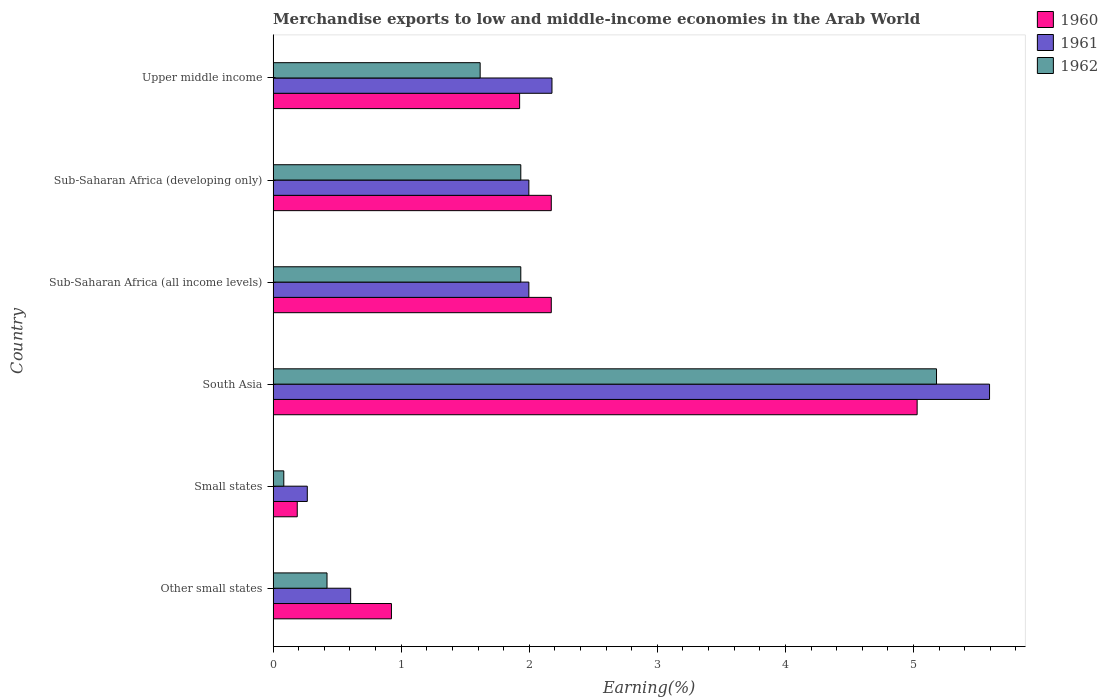How many groups of bars are there?
Keep it short and to the point. 6. Are the number of bars on each tick of the Y-axis equal?
Offer a terse response. Yes. How many bars are there on the 1st tick from the top?
Offer a terse response. 3. In how many cases, is the number of bars for a given country not equal to the number of legend labels?
Offer a terse response. 0. What is the percentage of amount earned from merchandise exports in 1961 in Sub-Saharan Africa (all income levels)?
Provide a succinct answer. 2. Across all countries, what is the maximum percentage of amount earned from merchandise exports in 1960?
Keep it short and to the point. 5.03. Across all countries, what is the minimum percentage of amount earned from merchandise exports in 1960?
Offer a very short reply. 0.19. In which country was the percentage of amount earned from merchandise exports in 1960 minimum?
Provide a succinct answer. Small states. What is the total percentage of amount earned from merchandise exports in 1962 in the graph?
Your answer should be very brief. 11.17. What is the difference between the percentage of amount earned from merchandise exports in 1960 in Small states and that in South Asia?
Provide a short and direct response. -4.84. What is the difference between the percentage of amount earned from merchandise exports in 1960 in Sub-Saharan Africa (developing only) and the percentage of amount earned from merchandise exports in 1962 in South Asia?
Provide a succinct answer. -3.01. What is the average percentage of amount earned from merchandise exports in 1961 per country?
Your answer should be compact. 2.11. What is the difference between the percentage of amount earned from merchandise exports in 1962 and percentage of amount earned from merchandise exports in 1961 in Small states?
Give a very brief answer. -0.18. In how many countries, is the percentage of amount earned from merchandise exports in 1961 greater than 2.2 %?
Give a very brief answer. 1. What is the ratio of the percentage of amount earned from merchandise exports in 1960 in Small states to that in Upper middle income?
Keep it short and to the point. 0.1. Is the percentage of amount earned from merchandise exports in 1961 in South Asia less than that in Sub-Saharan Africa (developing only)?
Offer a terse response. No. Is the difference between the percentage of amount earned from merchandise exports in 1962 in Sub-Saharan Africa (all income levels) and Sub-Saharan Africa (developing only) greater than the difference between the percentage of amount earned from merchandise exports in 1961 in Sub-Saharan Africa (all income levels) and Sub-Saharan Africa (developing only)?
Your answer should be compact. No. What is the difference between the highest and the second highest percentage of amount earned from merchandise exports in 1962?
Your answer should be compact. 3.25. What is the difference between the highest and the lowest percentage of amount earned from merchandise exports in 1962?
Your answer should be compact. 5.1. In how many countries, is the percentage of amount earned from merchandise exports in 1962 greater than the average percentage of amount earned from merchandise exports in 1962 taken over all countries?
Provide a short and direct response. 3. Is the sum of the percentage of amount earned from merchandise exports in 1962 in Other small states and Sub-Saharan Africa (developing only) greater than the maximum percentage of amount earned from merchandise exports in 1961 across all countries?
Ensure brevity in your answer.  No. What does the 1st bar from the top in Small states represents?
Give a very brief answer. 1962. What does the 3rd bar from the bottom in South Asia represents?
Your answer should be very brief. 1962. How many bars are there?
Your response must be concise. 18. Are all the bars in the graph horizontal?
Your response must be concise. Yes. Where does the legend appear in the graph?
Your response must be concise. Top right. How many legend labels are there?
Your response must be concise. 3. How are the legend labels stacked?
Your answer should be compact. Vertical. What is the title of the graph?
Provide a short and direct response. Merchandise exports to low and middle-income economies in the Arab World. Does "1991" appear as one of the legend labels in the graph?
Make the answer very short. No. What is the label or title of the X-axis?
Give a very brief answer. Earning(%). What is the label or title of the Y-axis?
Make the answer very short. Country. What is the Earning(%) in 1960 in Other small states?
Provide a succinct answer. 0.92. What is the Earning(%) in 1961 in Other small states?
Provide a succinct answer. 0.61. What is the Earning(%) of 1962 in Other small states?
Offer a very short reply. 0.42. What is the Earning(%) of 1960 in Small states?
Keep it short and to the point. 0.19. What is the Earning(%) in 1961 in Small states?
Ensure brevity in your answer.  0.27. What is the Earning(%) in 1962 in Small states?
Your answer should be very brief. 0.08. What is the Earning(%) in 1960 in South Asia?
Provide a succinct answer. 5.03. What is the Earning(%) in 1961 in South Asia?
Offer a very short reply. 5.59. What is the Earning(%) of 1962 in South Asia?
Your response must be concise. 5.18. What is the Earning(%) of 1960 in Sub-Saharan Africa (all income levels)?
Your answer should be very brief. 2.17. What is the Earning(%) in 1961 in Sub-Saharan Africa (all income levels)?
Your answer should be compact. 2. What is the Earning(%) in 1962 in Sub-Saharan Africa (all income levels)?
Provide a succinct answer. 1.93. What is the Earning(%) of 1960 in Sub-Saharan Africa (developing only)?
Make the answer very short. 2.17. What is the Earning(%) in 1961 in Sub-Saharan Africa (developing only)?
Provide a short and direct response. 2. What is the Earning(%) of 1962 in Sub-Saharan Africa (developing only)?
Make the answer very short. 1.93. What is the Earning(%) of 1960 in Upper middle income?
Your answer should be very brief. 1.92. What is the Earning(%) of 1961 in Upper middle income?
Offer a very short reply. 2.18. What is the Earning(%) of 1962 in Upper middle income?
Keep it short and to the point. 1.62. Across all countries, what is the maximum Earning(%) in 1960?
Your answer should be compact. 5.03. Across all countries, what is the maximum Earning(%) of 1961?
Provide a short and direct response. 5.59. Across all countries, what is the maximum Earning(%) in 1962?
Your response must be concise. 5.18. Across all countries, what is the minimum Earning(%) of 1960?
Your response must be concise. 0.19. Across all countries, what is the minimum Earning(%) in 1961?
Offer a terse response. 0.27. Across all countries, what is the minimum Earning(%) of 1962?
Provide a short and direct response. 0.08. What is the total Earning(%) of 1960 in the graph?
Your answer should be compact. 12.41. What is the total Earning(%) in 1961 in the graph?
Provide a succinct answer. 12.64. What is the total Earning(%) of 1962 in the graph?
Provide a short and direct response. 11.17. What is the difference between the Earning(%) in 1960 in Other small states and that in Small states?
Provide a short and direct response. 0.74. What is the difference between the Earning(%) in 1961 in Other small states and that in Small states?
Your response must be concise. 0.34. What is the difference between the Earning(%) of 1962 in Other small states and that in Small states?
Make the answer very short. 0.34. What is the difference between the Earning(%) in 1960 in Other small states and that in South Asia?
Offer a terse response. -4.1. What is the difference between the Earning(%) of 1961 in Other small states and that in South Asia?
Your response must be concise. -4.99. What is the difference between the Earning(%) in 1962 in Other small states and that in South Asia?
Your answer should be very brief. -4.76. What is the difference between the Earning(%) of 1960 in Other small states and that in Sub-Saharan Africa (all income levels)?
Your answer should be very brief. -1.25. What is the difference between the Earning(%) in 1961 in Other small states and that in Sub-Saharan Africa (all income levels)?
Your answer should be very brief. -1.39. What is the difference between the Earning(%) in 1962 in Other small states and that in Sub-Saharan Africa (all income levels)?
Keep it short and to the point. -1.51. What is the difference between the Earning(%) in 1960 in Other small states and that in Sub-Saharan Africa (developing only)?
Keep it short and to the point. -1.25. What is the difference between the Earning(%) in 1961 in Other small states and that in Sub-Saharan Africa (developing only)?
Ensure brevity in your answer.  -1.39. What is the difference between the Earning(%) in 1962 in Other small states and that in Sub-Saharan Africa (developing only)?
Your answer should be compact. -1.51. What is the difference between the Earning(%) in 1960 in Other small states and that in Upper middle income?
Offer a terse response. -1. What is the difference between the Earning(%) in 1961 in Other small states and that in Upper middle income?
Keep it short and to the point. -1.57. What is the difference between the Earning(%) in 1962 in Other small states and that in Upper middle income?
Offer a terse response. -1.2. What is the difference between the Earning(%) in 1960 in Small states and that in South Asia?
Provide a succinct answer. -4.84. What is the difference between the Earning(%) of 1961 in Small states and that in South Asia?
Ensure brevity in your answer.  -5.33. What is the difference between the Earning(%) of 1962 in Small states and that in South Asia?
Provide a short and direct response. -5.1. What is the difference between the Earning(%) in 1960 in Small states and that in Sub-Saharan Africa (all income levels)?
Ensure brevity in your answer.  -1.98. What is the difference between the Earning(%) of 1961 in Small states and that in Sub-Saharan Africa (all income levels)?
Provide a short and direct response. -1.73. What is the difference between the Earning(%) in 1962 in Small states and that in Sub-Saharan Africa (all income levels)?
Your response must be concise. -1.85. What is the difference between the Earning(%) in 1960 in Small states and that in Sub-Saharan Africa (developing only)?
Ensure brevity in your answer.  -1.98. What is the difference between the Earning(%) in 1961 in Small states and that in Sub-Saharan Africa (developing only)?
Keep it short and to the point. -1.73. What is the difference between the Earning(%) in 1962 in Small states and that in Sub-Saharan Africa (developing only)?
Offer a very short reply. -1.85. What is the difference between the Earning(%) in 1960 in Small states and that in Upper middle income?
Make the answer very short. -1.74. What is the difference between the Earning(%) in 1961 in Small states and that in Upper middle income?
Provide a short and direct response. -1.91. What is the difference between the Earning(%) of 1962 in Small states and that in Upper middle income?
Ensure brevity in your answer.  -1.53. What is the difference between the Earning(%) in 1960 in South Asia and that in Sub-Saharan Africa (all income levels)?
Provide a succinct answer. 2.86. What is the difference between the Earning(%) of 1961 in South Asia and that in Sub-Saharan Africa (all income levels)?
Make the answer very short. 3.6. What is the difference between the Earning(%) of 1962 in South Asia and that in Sub-Saharan Africa (all income levels)?
Offer a very short reply. 3.25. What is the difference between the Earning(%) in 1960 in South Asia and that in Sub-Saharan Africa (developing only)?
Offer a very short reply. 2.86. What is the difference between the Earning(%) of 1961 in South Asia and that in Sub-Saharan Africa (developing only)?
Ensure brevity in your answer.  3.6. What is the difference between the Earning(%) in 1962 in South Asia and that in Sub-Saharan Africa (developing only)?
Provide a short and direct response. 3.25. What is the difference between the Earning(%) in 1960 in South Asia and that in Upper middle income?
Offer a terse response. 3.1. What is the difference between the Earning(%) of 1961 in South Asia and that in Upper middle income?
Give a very brief answer. 3.42. What is the difference between the Earning(%) in 1962 in South Asia and that in Upper middle income?
Offer a very short reply. 3.56. What is the difference between the Earning(%) of 1960 in Sub-Saharan Africa (all income levels) and that in Sub-Saharan Africa (developing only)?
Your answer should be very brief. 0. What is the difference between the Earning(%) of 1961 in Sub-Saharan Africa (all income levels) and that in Sub-Saharan Africa (developing only)?
Provide a short and direct response. 0. What is the difference between the Earning(%) of 1960 in Sub-Saharan Africa (all income levels) and that in Upper middle income?
Ensure brevity in your answer.  0.25. What is the difference between the Earning(%) in 1961 in Sub-Saharan Africa (all income levels) and that in Upper middle income?
Keep it short and to the point. -0.18. What is the difference between the Earning(%) in 1962 in Sub-Saharan Africa (all income levels) and that in Upper middle income?
Make the answer very short. 0.32. What is the difference between the Earning(%) in 1960 in Sub-Saharan Africa (developing only) and that in Upper middle income?
Your response must be concise. 0.25. What is the difference between the Earning(%) in 1961 in Sub-Saharan Africa (developing only) and that in Upper middle income?
Offer a terse response. -0.18. What is the difference between the Earning(%) in 1962 in Sub-Saharan Africa (developing only) and that in Upper middle income?
Ensure brevity in your answer.  0.32. What is the difference between the Earning(%) in 1960 in Other small states and the Earning(%) in 1961 in Small states?
Give a very brief answer. 0.66. What is the difference between the Earning(%) in 1960 in Other small states and the Earning(%) in 1962 in Small states?
Keep it short and to the point. 0.84. What is the difference between the Earning(%) of 1961 in Other small states and the Earning(%) of 1962 in Small states?
Your answer should be very brief. 0.52. What is the difference between the Earning(%) of 1960 in Other small states and the Earning(%) of 1961 in South Asia?
Offer a terse response. -4.67. What is the difference between the Earning(%) in 1960 in Other small states and the Earning(%) in 1962 in South Asia?
Provide a succinct answer. -4.26. What is the difference between the Earning(%) of 1961 in Other small states and the Earning(%) of 1962 in South Asia?
Your answer should be compact. -4.57. What is the difference between the Earning(%) in 1960 in Other small states and the Earning(%) in 1961 in Sub-Saharan Africa (all income levels)?
Your answer should be very brief. -1.07. What is the difference between the Earning(%) of 1960 in Other small states and the Earning(%) of 1962 in Sub-Saharan Africa (all income levels)?
Offer a very short reply. -1.01. What is the difference between the Earning(%) of 1961 in Other small states and the Earning(%) of 1962 in Sub-Saharan Africa (all income levels)?
Your answer should be compact. -1.33. What is the difference between the Earning(%) of 1960 in Other small states and the Earning(%) of 1961 in Sub-Saharan Africa (developing only)?
Your response must be concise. -1.07. What is the difference between the Earning(%) in 1960 in Other small states and the Earning(%) in 1962 in Sub-Saharan Africa (developing only)?
Your response must be concise. -1.01. What is the difference between the Earning(%) in 1961 in Other small states and the Earning(%) in 1962 in Sub-Saharan Africa (developing only)?
Offer a terse response. -1.33. What is the difference between the Earning(%) of 1960 in Other small states and the Earning(%) of 1961 in Upper middle income?
Ensure brevity in your answer.  -1.25. What is the difference between the Earning(%) in 1960 in Other small states and the Earning(%) in 1962 in Upper middle income?
Offer a very short reply. -0.69. What is the difference between the Earning(%) of 1961 in Other small states and the Earning(%) of 1962 in Upper middle income?
Give a very brief answer. -1.01. What is the difference between the Earning(%) in 1960 in Small states and the Earning(%) in 1961 in South Asia?
Your answer should be compact. -5.41. What is the difference between the Earning(%) of 1960 in Small states and the Earning(%) of 1962 in South Asia?
Offer a terse response. -4.99. What is the difference between the Earning(%) of 1961 in Small states and the Earning(%) of 1962 in South Asia?
Your answer should be compact. -4.91. What is the difference between the Earning(%) of 1960 in Small states and the Earning(%) of 1961 in Sub-Saharan Africa (all income levels)?
Ensure brevity in your answer.  -1.81. What is the difference between the Earning(%) of 1960 in Small states and the Earning(%) of 1962 in Sub-Saharan Africa (all income levels)?
Your answer should be compact. -1.75. What is the difference between the Earning(%) of 1961 in Small states and the Earning(%) of 1962 in Sub-Saharan Africa (all income levels)?
Ensure brevity in your answer.  -1.67. What is the difference between the Earning(%) in 1960 in Small states and the Earning(%) in 1961 in Sub-Saharan Africa (developing only)?
Keep it short and to the point. -1.81. What is the difference between the Earning(%) in 1960 in Small states and the Earning(%) in 1962 in Sub-Saharan Africa (developing only)?
Ensure brevity in your answer.  -1.75. What is the difference between the Earning(%) of 1961 in Small states and the Earning(%) of 1962 in Sub-Saharan Africa (developing only)?
Provide a short and direct response. -1.67. What is the difference between the Earning(%) in 1960 in Small states and the Earning(%) in 1961 in Upper middle income?
Your response must be concise. -1.99. What is the difference between the Earning(%) of 1960 in Small states and the Earning(%) of 1962 in Upper middle income?
Offer a very short reply. -1.43. What is the difference between the Earning(%) in 1961 in Small states and the Earning(%) in 1962 in Upper middle income?
Offer a terse response. -1.35. What is the difference between the Earning(%) in 1960 in South Asia and the Earning(%) in 1961 in Sub-Saharan Africa (all income levels)?
Offer a terse response. 3.03. What is the difference between the Earning(%) of 1960 in South Asia and the Earning(%) of 1962 in Sub-Saharan Africa (all income levels)?
Your response must be concise. 3.09. What is the difference between the Earning(%) of 1961 in South Asia and the Earning(%) of 1962 in Sub-Saharan Africa (all income levels)?
Make the answer very short. 3.66. What is the difference between the Earning(%) in 1960 in South Asia and the Earning(%) in 1961 in Sub-Saharan Africa (developing only)?
Offer a very short reply. 3.03. What is the difference between the Earning(%) of 1960 in South Asia and the Earning(%) of 1962 in Sub-Saharan Africa (developing only)?
Give a very brief answer. 3.09. What is the difference between the Earning(%) of 1961 in South Asia and the Earning(%) of 1962 in Sub-Saharan Africa (developing only)?
Make the answer very short. 3.66. What is the difference between the Earning(%) of 1960 in South Asia and the Earning(%) of 1961 in Upper middle income?
Your answer should be very brief. 2.85. What is the difference between the Earning(%) of 1960 in South Asia and the Earning(%) of 1962 in Upper middle income?
Your answer should be very brief. 3.41. What is the difference between the Earning(%) in 1961 in South Asia and the Earning(%) in 1962 in Upper middle income?
Offer a very short reply. 3.98. What is the difference between the Earning(%) in 1960 in Sub-Saharan Africa (all income levels) and the Earning(%) in 1961 in Sub-Saharan Africa (developing only)?
Offer a terse response. 0.18. What is the difference between the Earning(%) in 1960 in Sub-Saharan Africa (all income levels) and the Earning(%) in 1962 in Sub-Saharan Africa (developing only)?
Your response must be concise. 0.24. What is the difference between the Earning(%) of 1961 in Sub-Saharan Africa (all income levels) and the Earning(%) of 1962 in Sub-Saharan Africa (developing only)?
Make the answer very short. 0.06. What is the difference between the Earning(%) in 1960 in Sub-Saharan Africa (all income levels) and the Earning(%) in 1961 in Upper middle income?
Give a very brief answer. -0.01. What is the difference between the Earning(%) of 1960 in Sub-Saharan Africa (all income levels) and the Earning(%) of 1962 in Upper middle income?
Provide a short and direct response. 0.56. What is the difference between the Earning(%) in 1961 in Sub-Saharan Africa (all income levels) and the Earning(%) in 1962 in Upper middle income?
Your answer should be compact. 0.38. What is the difference between the Earning(%) in 1960 in Sub-Saharan Africa (developing only) and the Earning(%) in 1961 in Upper middle income?
Give a very brief answer. -0.01. What is the difference between the Earning(%) of 1960 in Sub-Saharan Africa (developing only) and the Earning(%) of 1962 in Upper middle income?
Provide a short and direct response. 0.56. What is the difference between the Earning(%) of 1961 in Sub-Saharan Africa (developing only) and the Earning(%) of 1962 in Upper middle income?
Provide a short and direct response. 0.38. What is the average Earning(%) of 1960 per country?
Provide a short and direct response. 2.07. What is the average Earning(%) in 1961 per country?
Ensure brevity in your answer.  2.11. What is the average Earning(%) of 1962 per country?
Ensure brevity in your answer.  1.86. What is the difference between the Earning(%) of 1960 and Earning(%) of 1961 in Other small states?
Offer a very short reply. 0.32. What is the difference between the Earning(%) in 1960 and Earning(%) in 1962 in Other small states?
Offer a terse response. 0.5. What is the difference between the Earning(%) of 1961 and Earning(%) of 1962 in Other small states?
Make the answer very short. 0.18. What is the difference between the Earning(%) of 1960 and Earning(%) of 1961 in Small states?
Offer a very short reply. -0.08. What is the difference between the Earning(%) of 1960 and Earning(%) of 1962 in Small states?
Your response must be concise. 0.11. What is the difference between the Earning(%) of 1961 and Earning(%) of 1962 in Small states?
Offer a terse response. 0.18. What is the difference between the Earning(%) of 1960 and Earning(%) of 1961 in South Asia?
Provide a succinct answer. -0.57. What is the difference between the Earning(%) of 1960 and Earning(%) of 1962 in South Asia?
Offer a terse response. -0.15. What is the difference between the Earning(%) of 1961 and Earning(%) of 1962 in South Asia?
Make the answer very short. 0.41. What is the difference between the Earning(%) in 1960 and Earning(%) in 1961 in Sub-Saharan Africa (all income levels)?
Offer a terse response. 0.18. What is the difference between the Earning(%) of 1960 and Earning(%) of 1962 in Sub-Saharan Africa (all income levels)?
Provide a succinct answer. 0.24. What is the difference between the Earning(%) in 1961 and Earning(%) in 1962 in Sub-Saharan Africa (all income levels)?
Offer a terse response. 0.06. What is the difference between the Earning(%) in 1960 and Earning(%) in 1961 in Sub-Saharan Africa (developing only)?
Provide a short and direct response. 0.18. What is the difference between the Earning(%) in 1960 and Earning(%) in 1962 in Sub-Saharan Africa (developing only)?
Offer a terse response. 0.24. What is the difference between the Earning(%) in 1961 and Earning(%) in 1962 in Sub-Saharan Africa (developing only)?
Your answer should be very brief. 0.06. What is the difference between the Earning(%) of 1960 and Earning(%) of 1961 in Upper middle income?
Provide a short and direct response. -0.25. What is the difference between the Earning(%) of 1960 and Earning(%) of 1962 in Upper middle income?
Provide a succinct answer. 0.31. What is the difference between the Earning(%) of 1961 and Earning(%) of 1962 in Upper middle income?
Keep it short and to the point. 0.56. What is the ratio of the Earning(%) in 1960 in Other small states to that in Small states?
Provide a short and direct response. 4.9. What is the ratio of the Earning(%) of 1961 in Other small states to that in Small states?
Offer a terse response. 2.27. What is the ratio of the Earning(%) of 1962 in Other small states to that in Small states?
Offer a terse response. 5.05. What is the ratio of the Earning(%) in 1960 in Other small states to that in South Asia?
Make the answer very short. 0.18. What is the ratio of the Earning(%) in 1961 in Other small states to that in South Asia?
Provide a short and direct response. 0.11. What is the ratio of the Earning(%) in 1962 in Other small states to that in South Asia?
Offer a very short reply. 0.08. What is the ratio of the Earning(%) in 1960 in Other small states to that in Sub-Saharan Africa (all income levels)?
Your response must be concise. 0.43. What is the ratio of the Earning(%) in 1961 in Other small states to that in Sub-Saharan Africa (all income levels)?
Your answer should be very brief. 0.3. What is the ratio of the Earning(%) in 1962 in Other small states to that in Sub-Saharan Africa (all income levels)?
Keep it short and to the point. 0.22. What is the ratio of the Earning(%) of 1960 in Other small states to that in Sub-Saharan Africa (developing only)?
Your answer should be compact. 0.43. What is the ratio of the Earning(%) in 1961 in Other small states to that in Sub-Saharan Africa (developing only)?
Make the answer very short. 0.3. What is the ratio of the Earning(%) of 1962 in Other small states to that in Sub-Saharan Africa (developing only)?
Your answer should be compact. 0.22. What is the ratio of the Earning(%) of 1960 in Other small states to that in Upper middle income?
Provide a succinct answer. 0.48. What is the ratio of the Earning(%) in 1961 in Other small states to that in Upper middle income?
Provide a succinct answer. 0.28. What is the ratio of the Earning(%) in 1962 in Other small states to that in Upper middle income?
Ensure brevity in your answer.  0.26. What is the ratio of the Earning(%) of 1960 in Small states to that in South Asia?
Your answer should be very brief. 0.04. What is the ratio of the Earning(%) in 1961 in Small states to that in South Asia?
Your answer should be very brief. 0.05. What is the ratio of the Earning(%) of 1962 in Small states to that in South Asia?
Give a very brief answer. 0.02. What is the ratio of the Earning(%) of 1960 in Small states to that in Sub-Saharan Africa (all income levels)?
Provide a succinct answer. 0.09. What is the ratio of the Earning(%) of 1961 in Small states to that in Sub-Saharan Africa (all income levels)?
Your answer should be compact. 0.13. What is the ratio of the Earning(%) of 1962 in Small states to that in Sub-Saharan Africa (all income levels)?
Ensure brevity in your answer.  0.04. What is the ratio of the Earning(%) in 1960 in Small states to that in Sub-Saharan Africa (developing only)?
Give a very brief answer. 0.09. What is the ratio of the Earning(%) of 1961 in Small states to that in Sub-Saharan Africa (developing only)?
Offer a very short reply. 0.13. What is the ratio of the Earning(%) of 1962 in Small states to that in Sub-Saharan Africa (developing only)?
Provide a short and direct response. 0.04. What is the ratio of the Earning(%) in 1960 in Small states to that in Upper middle income?
Offer a terse response. 0.1. What is the ratio of the Earning(%) in 1961 in Small states to that in Upper middle income?
Ensure brevity in your answer.  0.12. What is the ratio of the Earning(%) of 1962 in Small states to that in Upper middle income?
Give a very brief answer. 0.05. What is the ratio of the Earning(%) of 1960 in South Asia to that in Sub-Saharan Africa (all income levels)?
Your answer should be compact. 2.32. What is the ratio of the Earning(%) in 1961 in South Asia to that in Sub-Saharan Africa (all income levels)?
Your answer should be compact. 2.8. What is the ratio of the Earning(%) of 1962 in South Asia to that in Sub-Saharan Africa (all income levels)?
Make the answer very short. 2.68. What is the ratio of the Earning(%) in 1960 in South Asia to that in Sub-Saharan Africa (developing only)?
Ensure brevity in your answer.  2.32. What is the ratio of the Earning(%) of 1961 in South Asia to that in Sub-Saharan Africa (developing only)?
Your response must be concise. 2.8. What is the ratio of the Earning(%) in 1962 in South Asia to that in Sub-Saharan Africa (developing only)?
Ensure brevity in your answer.  2.68. What is the ratio of the Earning(%) in 1960 in South Asia to that in Upper middle income?
Offer a very short reply. 2.61. What is the ratio of the Earning(%) in 1961 in South Asia to that in Upper middle income?
Offer a terse response. 2.57. What is the ratio of the Earning(%) of 1962 in South Asia to that in Upper middle income?
Offer a very short reply. 3.2. What is the ratio of the Earning(%) in 1960 in Sub-Saharan Africa (all income levels) to that in Sub-Saharan Africa (developing only)?
Give a very brief answer. 1. What is the ratio of the Earning(%) of 1960 in Sub-Saharan Africa (all income levels) to that in Upper middle income?
Offer a very short reply. 1.13. What is the ratio of the Earning(%) of 1961 in Sub-Saharan Africa (all income levels) to that in Upper middle income?
Offer a very short reply. 0.92. What is the ratio of the Earning(%) of 1962 in Sub-Saharan Africa (all income levels) to that in Upper middle income?
Give a very brief answer. 1.2. What is the ratio of the Earning(%) of 1960 in Sub-Saharan Africa (developing only) to that in Upper middle income?
Your answer should be compact. 1.13. What is the ratio of the Earning(%) in 1961 in Sub-Saharan Africa (developing only) to that in Upper middle income?
Keep it short and to the point. 0.92. What is the ratio of the Earning(%) of 1962 in Sub-Saharan Africa (developing only) to that in Upper middle income?
Make the answer very short. 1.2. What is the difference between the highest and the second highest Earning(%) of 1960?
Offer a terse response. 2.86. What is the difference between the highest and the second highest Earning(%) in 1961?
Your response must be concise. 3.42. What is the difference between the highest and the second highest Earning(%) in 1962?
Provide a succinct answer. 3.25. What is the difference between the highest and the lowest Earning(%) in 1960?
Provide a short and direct response. 4.84. What is the difference between the highest and the lowest Earning(%) in 1961?
Keep it short and to the point. 5.33. What is the difference between the highest and the lowest Earning(%) of 1962?
Give a very brief answer. 5.1. 